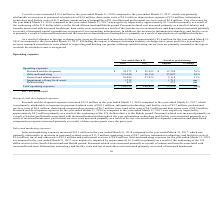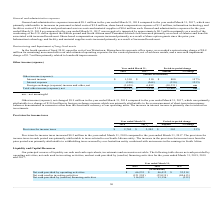According to Mimecast Limited's financial document, What was the increase in Research and development expense in 2018? According to the financial document, $15.8 million. The relevant text states: "Research and development expenses increased $15.8 million in the year ended March 31, 2018 compared to the year ended March 31, 2017, which..." Also, What was the Sales and marketing expenses in 2018 and 2017 respectively? The document shows two values: 121,246 and 96,154 (in thousands). From the document: "Sales and marketing 121,246 96,154 25,092 26% Sales and marketing 121,246 96,154 25,092 26%..." Also, What was the Research and development expenses in 2018 and 2017 respectively? The document shows two values: $38,373 and $22,593 (in thousands). From the document: "Research and development $ 38,373 $ 22,593 $ 15,780 70% Research and development $ 38,373 $ 22,593 $ 15,780 70%..." Also, can you calculate: What was the average Research and development expenses in 2017 and 2018? To answer this question, I need to perform calculations using the financial data. The calculation is: (38,373 + 22,593) / 2, which equals 30483 (in thousands). This is based on the information: "Research and development $ 38,373 $ 22,593 $ 15,780 70% Research and development $ 38,373 $ 22,593 $ 15,780 70%..." The key data points involved are: 22,593, 38,373. Also, can you calculate: What was the average Sales and marketing expenses in 2017 and 2018? To answer this question, I need to perform calculations using the financial data. The calculation is: (121,246 + 96,154) / 2, which equals 108700 (in thousands). This is based on the information: "Sales and marketing 121,246 96,154 25,092 26% Sales and marketing 121,246 96,154 25,092 26%..." The key data points involved are: 121,246, 96,154. Additionally, In which year was General and administrative expenses less than 30,000 thousands? According to the financial document, 2017. The relevant text states: "rch 31, 2018 compared to the year ended March 31, 2017, which was primarily..." 